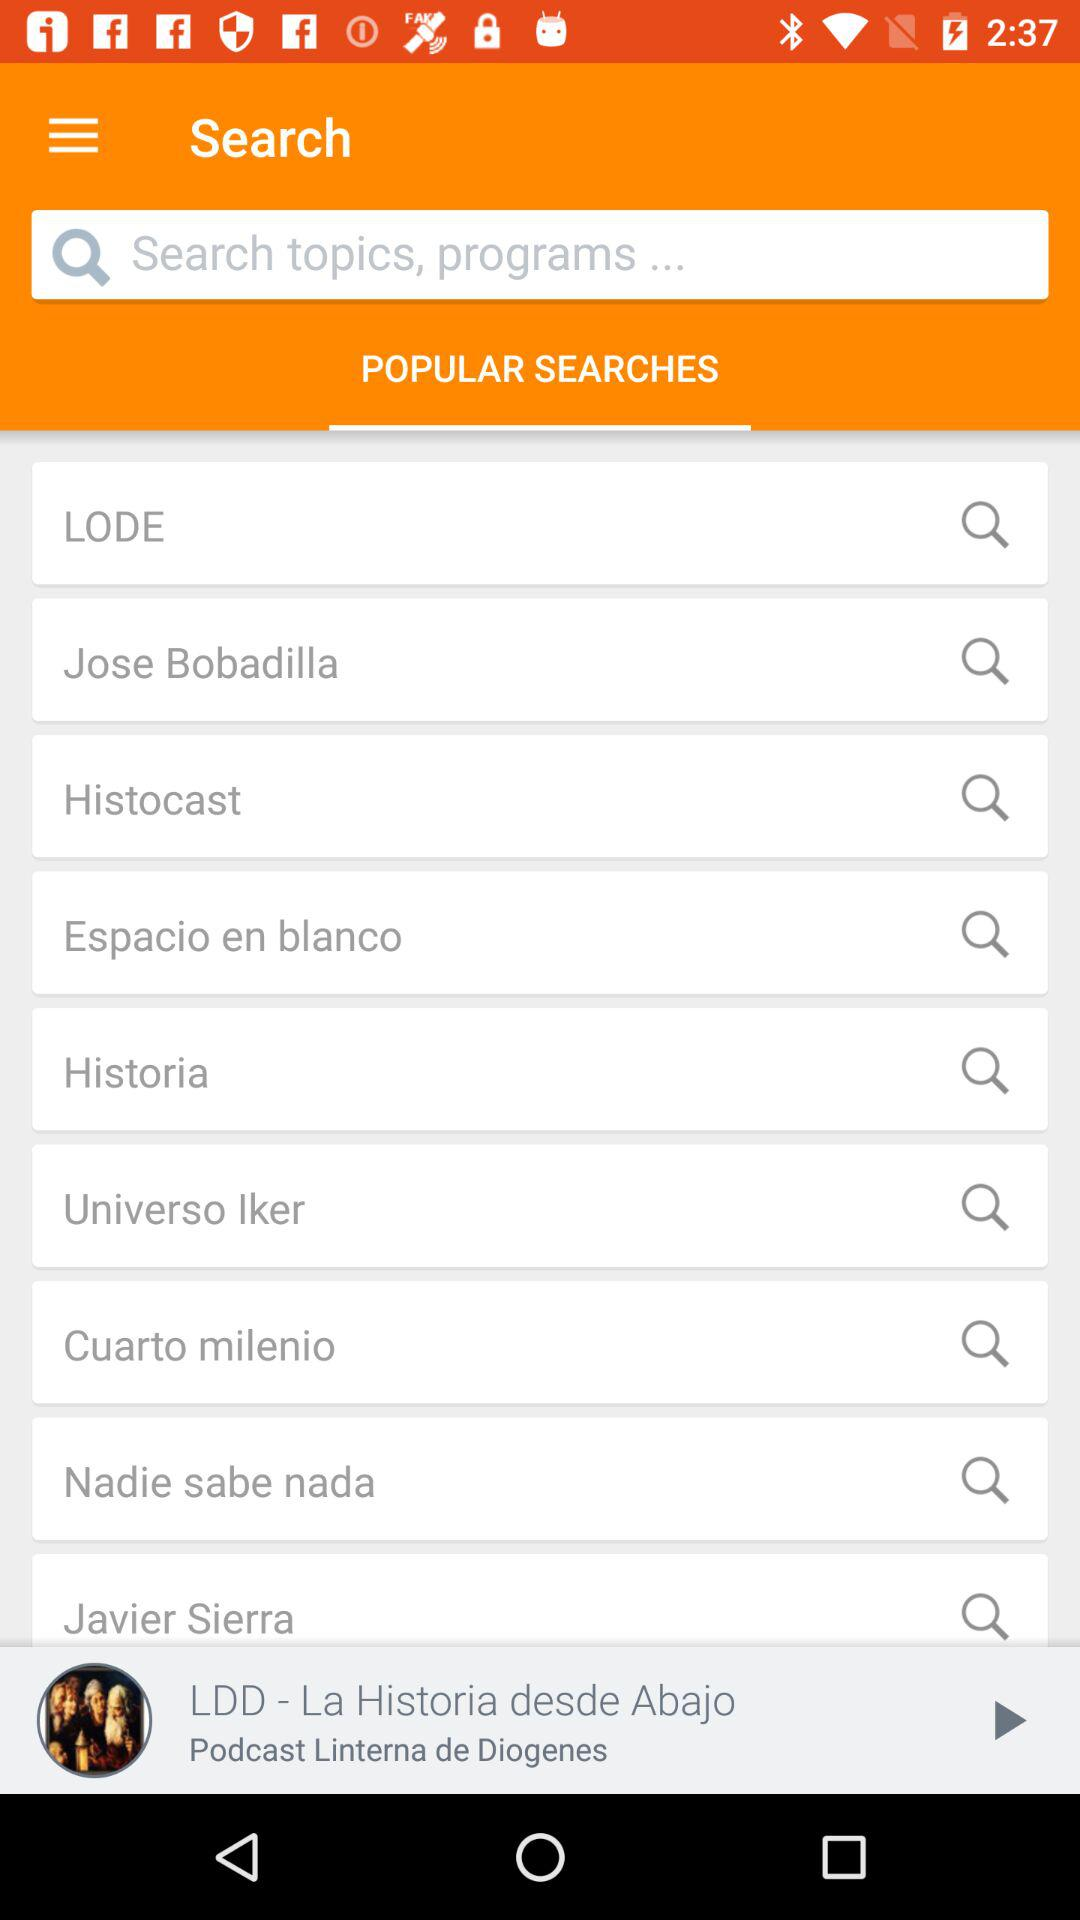What is the name of the application?
When the provided information is insufficient, respond with <no answer>. <no answer> 